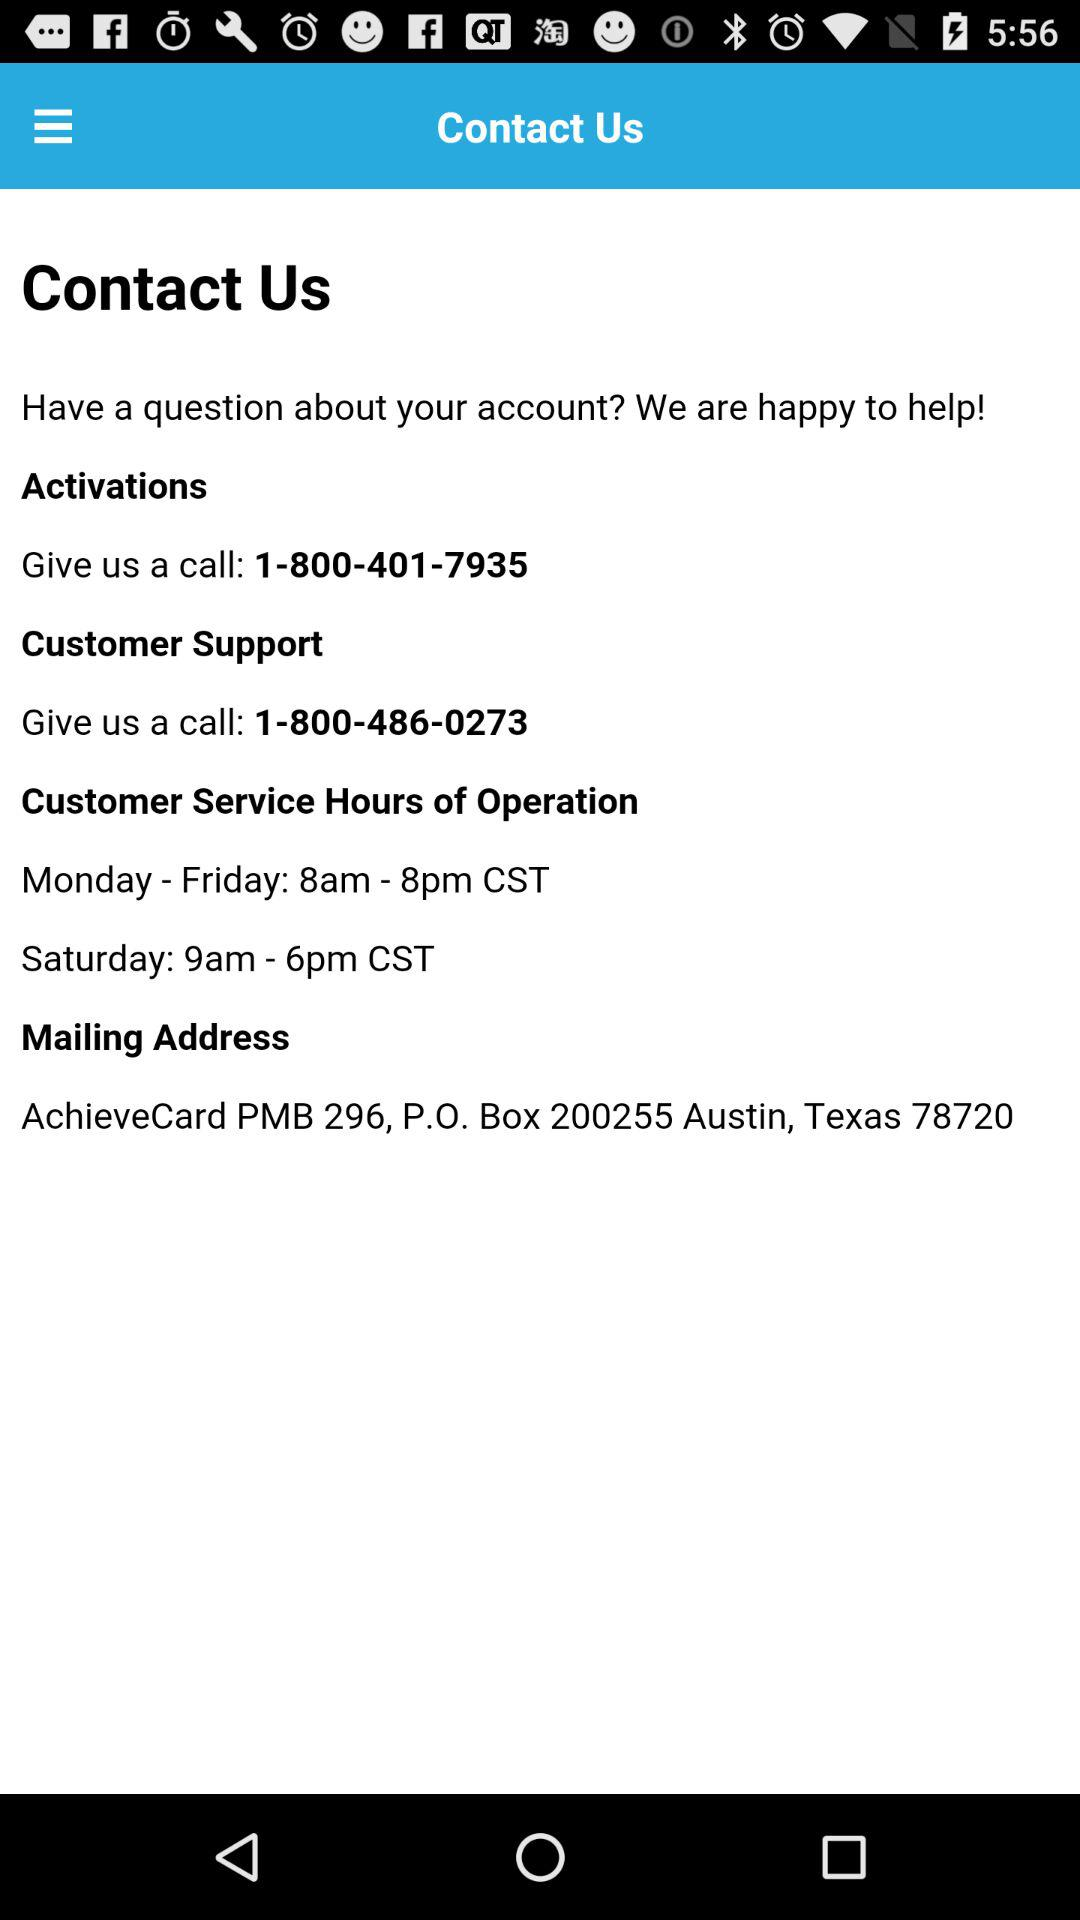What is the mailing address? The mailing address is AchieveCard PMB 296, P.O. Box 200255, Austin, Texas 78720. 